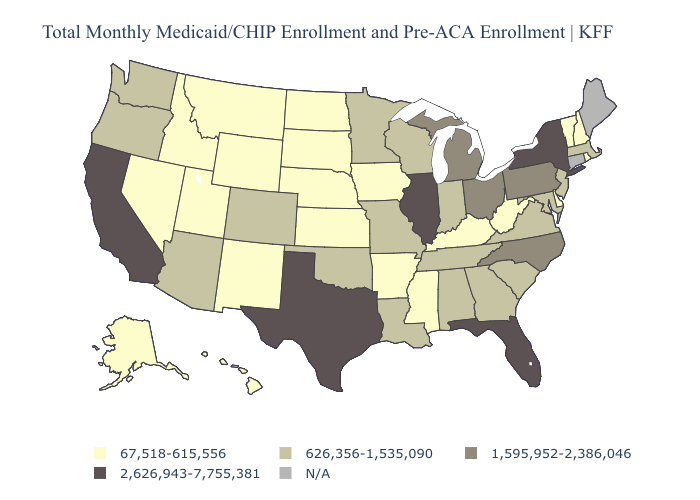Does Tennessee have the lowest value in the USA?
Give a very brief answer. No. Name the states that have a value in the range 2,626,943-7,755,381?
Quick response, please. California, Florida, Illinois, New York, Texas. Among the states that border Missouri , which have the lowest value?
Give a very brief answer. Arkansas, Iowa, Kansas, Kentucky, Nebraska. Is the legend a continuous bar?
Answer briefly. No. Name the states that have a value in the range 2,626,943-7,755,381?
Give a very brief answer. California, Florida, Illinois, New York, Texas. Name the states that have a value in the range 2,626,943-7,755,381?
Write a very short answer. California, Florida, Illinois, New York, Texas. What is the highest value in the USA?
Short answer required. 2,626,943-7,755,381. Name the states that have a value in the range 626,356-1,535,090?
Be succinct. Alabama, Arizona, Colorado, Georgia, Indiana, Louisiana, Maryland, Massachusetts, Minnesota, Missouri, New Jersey, Oklahoma, Oregon, South Carolina, Tennessee, Virginia, Washington, Wisconsin. Does Kansas have the lowest value in the MidWest?
Write a very short answer. Yes. What is the value of Louisiana?
Give a very brief answer. 626,356-1,535,090. Among the states that border North Dakota , which have the lowest value?
Write a very short answer. Montana, South Dakota. What is the highest value in the West ?
Be succinct. 2,626,943-7,755,381. Among the states that border Virginia , which have the lowest value?
Give a very brief answer. Kentucky, West Virginia. Does Arizona have the lowest value in the USA?
Short answer required. No. Is the legend a continuous bar?
Be succinct. No. 